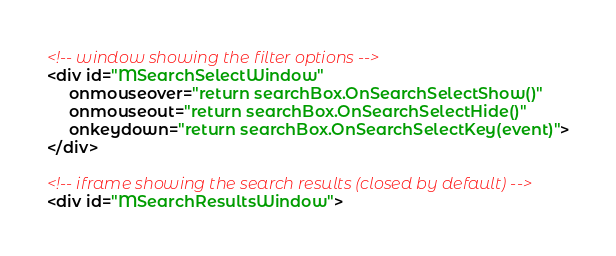<code> <loc_0><loc_0><loc_500><loc_500><_HTML_><!-- window showing the filter options -->
<div id="MSearchSelectWindow"
     onmouseover="return searchBox.OnSearchSelectShow()"
     onmouseout="return searchBox.OnSearchSelectHide()"
     onkeydown="return searchBox.OnSearchSelectKey(event)">
</div>

<!-- iframe showing the search results (closed by default) -->
<div id="MSearchResultsWindow"></code> 